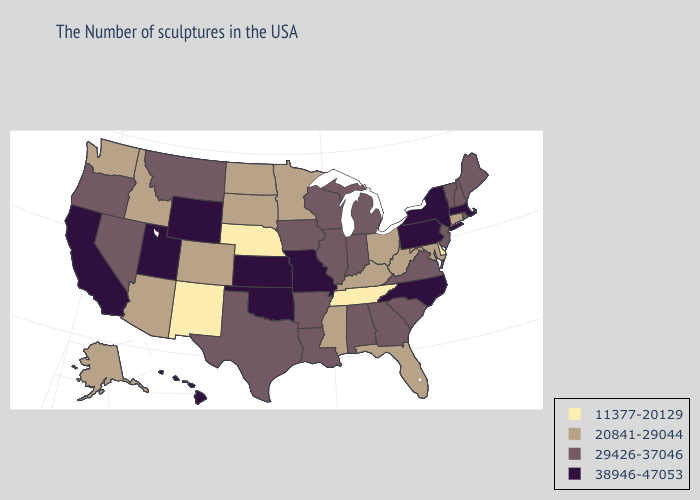What is the lowest value in the MidWest?
Quick response, please. 11377-20129. Does Colorado have a higher value than Alabama?
Write a very short answer. No. Among the states that border Indiana , does Ohio have the highest value?
Give a very brief answer. No. Name the states that have a value in the range 29426-37046?
Keep it brief. Maine, Rhode Island, New Hampshire, Vermont, New Jersey, Virginia, South Carolina, Georgia, Michigan, Indiana, Alabama, Wisconsin, Illinois, Louisiana, Arkansas, Iowa, Texas, Montana, Nevada, Oregon. Does Utah have the highest value in the USA?
Give a very brief answer. Yes. What is the value of Alabama?
Be succinct. 29426-37046. How many symbols are there in the legend?
Give a very brief answer. 4. What is the highest value in the South ?
Answer briefly. 38946-47053. Which states have the lowest value in the Northeast?
Give a very brief answer. Connecticut. Which states have the lowest value in the USA?
Quick response, please. Delaware, Tennessee, Nebraska, New Mexico. Which states hav the highest value in the West?
Answer briefly. Wyoming, Utah, California, Hawaii. What is the value of Georgia?
Concise answer only. 29426-37046. Which states hav the highest value in the Northeast?
Give a very brief answer. Massachusetts, New York, Pennsylvania. Among the states that border Oregon , does Washington have the lowest value?
Short answer required. Yes. Does Nebraska have the lowest value in the USA?
Write a very short answer. Yes. 